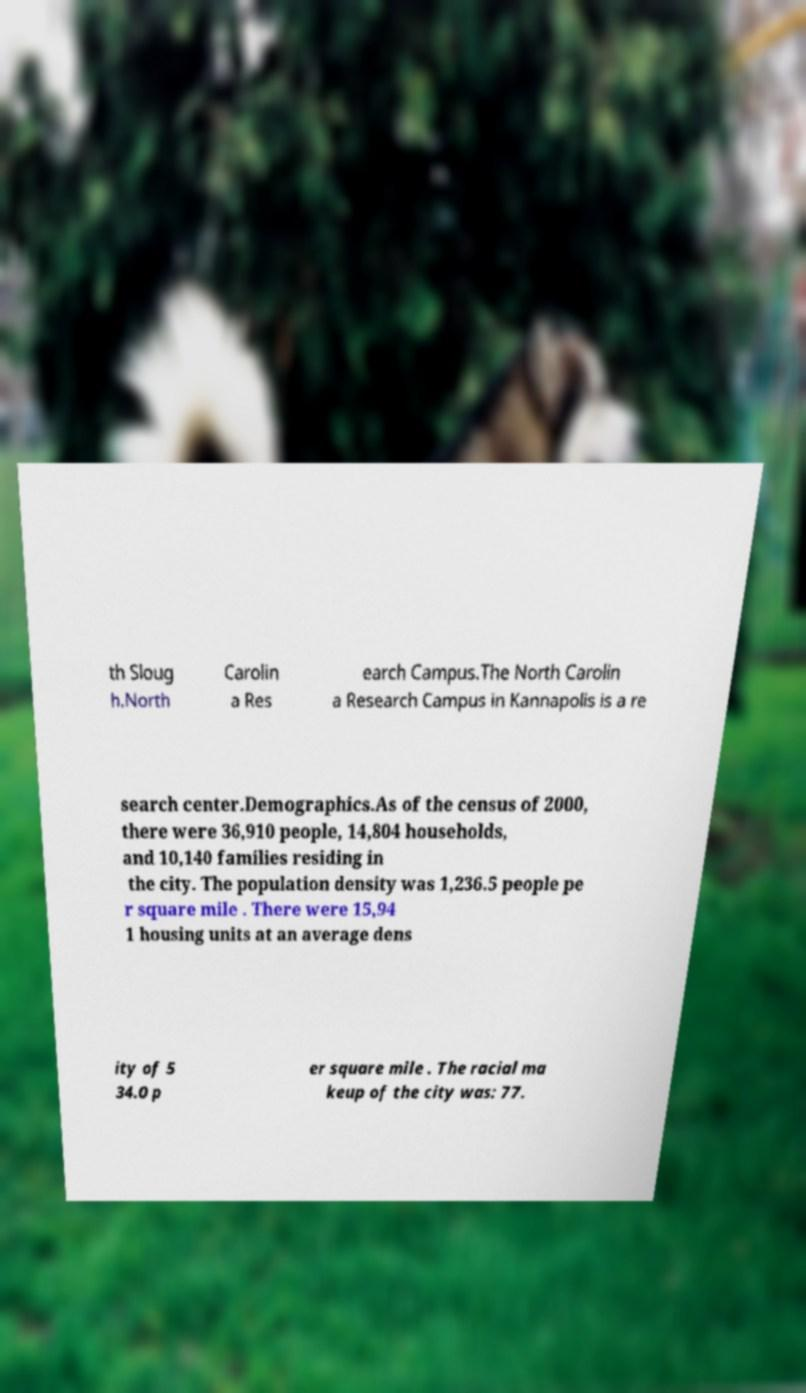For documentation purposes, I need the text within this image transcribed. Could you provide that? th Sloug h.North Carolin a Res earch Campus.The North Carolin a Research Campus in Kannapolis is a re search center.Demographics.As of the census of 2000, there were 36,910 people, 14,804 households, and 10,140 families residing in the city. The population density was 1,236.5 people pe r square mile . There were 15,94 1 housing units at an average dens ity of 5 34.0 p er square mile . The racial ma keup of the city was: 77. 